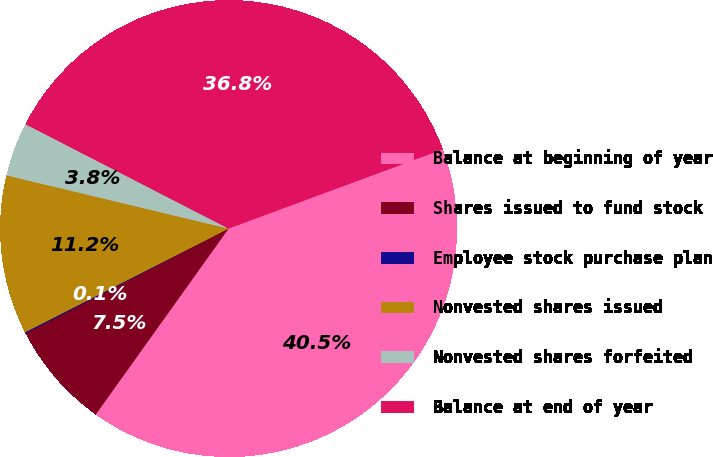Convert chart. <chart><loc_0><loc_0><loc_500><loc_500><pie_chart><fcel>Balance at beginning of year<fcel>Shares issued to fund stock<fcel>Employee stock purchase plan<fcel>Nonvested shares issued<fcel>Nonvested shares forfeited<fcel>Balance at end of year<nl><fcel>40.52%<fcel>7.53%<fcel>0.09%<fcel>11.25%<fcel>3.81%<fcel>36.8%<nl></chart> 